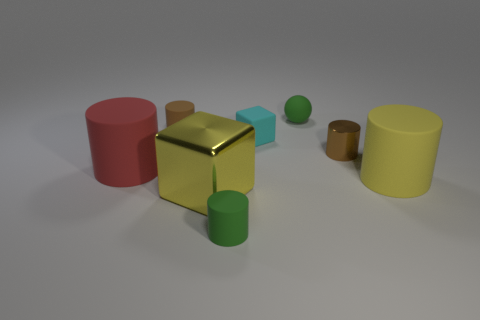What number of other small matte cubes have the same color as the matte block?
Keep it short and to the point. 0. Is the shiny cube the same color as the ball?
Provide a short and direct response. No. What is the large cylinder that is on the right side of the large yellow metallic block made of?
Your response must be concise. Rubber. What number of tiny things are yellow metallic cubes or brown cylinders?
Provide a short and direct response. 2. What material is the object that is the same color as the metal cube?
Provide a succinct answer. Rubber. Are there any gray spheres that have the same material as the big red cylinder?
Provide a short and direct response. No. There is a yellow object behind the yellow cube; does it have the same size as the shiny block?
Ensure brevity in your answer.  Yes. There is a green object behind the tiny brown rubber object that is behind the yellow matte cylinder; is there a big yellow metal object that is behind it?
Offer a terse response. No. What number of rubber things are either green spheres or brown cylinders?
Keep it short and to the point. 2. How many other objects are there of the same shape as the brown rubber object?
Keep it short and to the point. 4. 